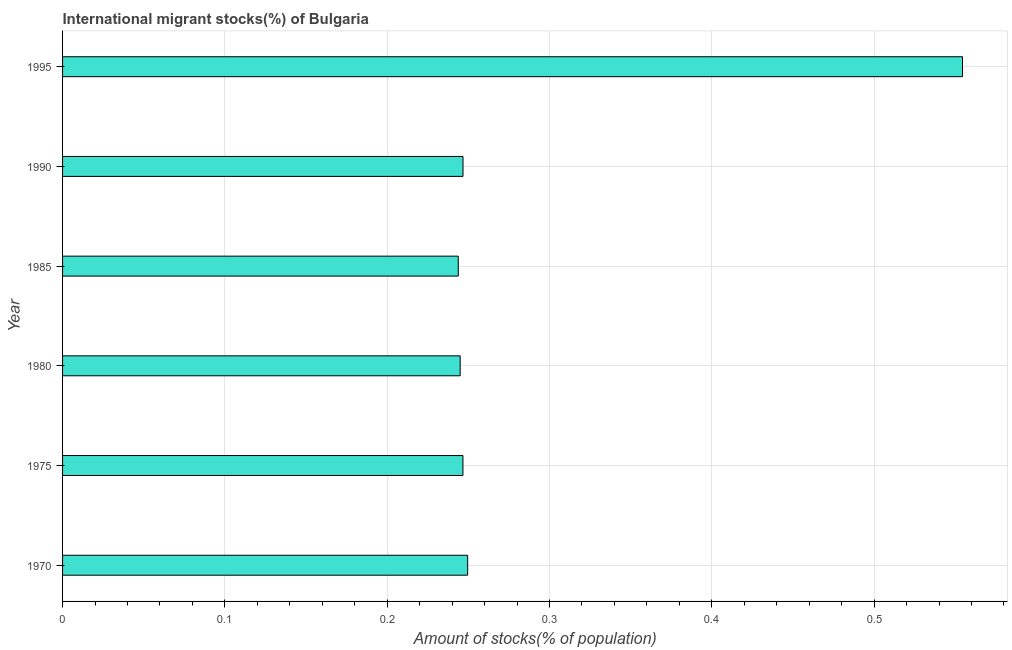What is the title of the graph?
Make the answer very short. International migrant stocks(%) of Bulgaria. What is the label or title of the X-axis?
Offer a very short reply. Amount of stocks(% of population). What is the label or title of the Y-axis?
Your answer should be very brief. Year. What is the number of international migrant stocks in 1970?
Offer a terse response. 0.25. Across all years, what is the maximum number of international migrant stocks?
Offer a terse response. 0.55. Across all years, what is the minimum number of international migrant stocks?
Keep it short and to the point. 0.24. In which year was the number of international migrant stocks maximum?
Keep it short and to the point. 1995. What is the sum of the number of international migrant stocks?
Your answer should be compact. 1.79. What is the difference between the number of international migrant stocks in 1975 and 1995?
Your response must be concise. -0.31. What is the average number of international migrant stocks per year?
Offer a terse response. 0.3. What is the median number of international migrant stocks?
Provide a succinct answer. 0.25. In how many years, is the number of international migrant stocks greater than 0.04 %?
Offer a terse response. 6. What is the ratio of the number of international migrant stocks in 1980 to that in 1995?
Ensure brevity in your answer.  0.44. What is the difference between the highest and the second highest number of international migrant stocks?
Offer a terse response. 0.3. What is the difference between the highest and the lowest number of international migrant stocks?
Keep it short and to the point. 0.31. How many bars are there?
Your answer should be very brief. 6. What is the difference between two consecutive major ticks on the X-axis?
Give a very brief answer. 0.1. Are the values on the major ticks of X-axis written in scientific E-notation?
Give a very brief answer. No. What is the Amount of stocks(% of population) of 1970?
Ensure brevity in your answer.  0.25. What is the Amount of stocks(% of population) of 1975?
Make the answer very short. 0.25. What is the Amount of stocks(% of population) of 1980?
Ensure brevity in your answer.  0.24. What is the Amount of stocks(% of population) in 1985?
Your answer should be very brief. 0.24. What is the Amount of stocks(% of population) in 1990?
Your response must be concise. 0.25. What is the Amount of stocks(% of population) of 1995?
Your response must be concise. 0.55. What is the difference between the Amount of stocks(% of population) in 1970 and 1975?
Offer a terse response. 0. What is the difference between the Amount of stocks(% of population) in 1970 and 1980?
Your response must be concise. 0. What is the difference between the Amount of stocks(% of population) in 1970 and 1985?
Your answer should be compact. 0.01. What is the difference between the Amount of stocks(% of population) in 1970 and 1990?
Your response must be concise. 0. What is the difference between the Amount of stocks(% of population) in 1970 and 1995?
Keep it short and to the point. -0.3. What is the difference between the Amount of stocks(% of population) in 1975 and 1980?
Give a very brief answer. 0. What is the difference between the Amount of stocks(% of population) in 1975 and 1985?
Provide a succinct answer. 0. What is the difference between the Amount of stocks(% of population) in 1975 and 1990?
Provide a short and direct response. -3e-5. What is the difference between the Amount of stocks(% of population) in 1975 and 1995?
Your answer should be compact. -0.31. What is the difference between the Amount of stocks(% of population) in 1980 and 1985?
Your response must be concise. 0. What is the difference between the Amount of stocks(% of population) in 1980 and 1990?
Your answer should be compact. -0. What is the difference between the Amount of stocks(% of population) in 1980 and 1995?
Provide a short and direct response. -0.31. What is the difference between the Amount of stocks(% of population) in 1985 and 1990?
Provide a short and direct response. -0. What is the difference between the Amount of stocks(% of population) in 1985 and 1995?
Your response must be concise. -0.31. What is the difference between the Amount of stocks(% of population) in 1990 and 1995?
Provide a short and direct response. -0.31. What is the ratio of the Amount of stocks(% of population) in 1970 to that in 1985?
Offer a terse response. 1.02. What is the ratio of the Amount of stocks(% of population) in 1970 to that in 1990?
Your response must be concise. 1.01. What is the ratio of the Amount of stocks(% of population) in 1970 to that in 1995?
Offer a terse response. 0.45. What is the ratio of the Amount of stocks(% of population) in 1975 to that in 1980?
Provide a short and direct response. 1.01. What is the ratio of the Amount of stocks(% of population) in 1975 to that in 1985?
Provide a short and direct response. 1.01. What is the ratio of the Amount of stocks(% of population) in 1975 to that in 1990?
Your answer should be compact. 1. What is the ratio of the Amount of stocks(% of population) in 1975 to that in 1995?
Provide a short and direct response. 0.45. What is the ratio of the Amount of stocks(% of population) in 1980 to that in 1985?
Your response must be concise. 1. What is the ratio of the Amount of stocks(% of population) in 1980 to that in 1990?
Ensure brevity in your answer.  0.99. What is the ratio of the Amount of stocks(% of population) in 1980 to that in 1995?
Make the answer very short. 0.44. What is the ratio of the Amount of stocks(% of population) in 1985 to that in 1990?
Keep it short and to the point. 0.99. What is the ratio of the Amount of stocks(% of population) in 1985 to that in 1995?
Your answer should be very brief. 0.44. What is the ratio of the Amount of stocks(% of population) in 1990 to that in 1995?
Offer a terse response. 0.45. 